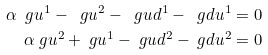<formula> <loc_0><loc_0><loc_500><loc_500>\ \alpha \ g u ^ { 1 } - \ g u ^ { 2 } - \ g u d ^ { 1 } - \ g d u ^ { 1 } & = 0 \\ \alpha \ g u ^ { 2 } + \ g u ^ { 1 } - \ g u d ^ { 2 } - \ g d u ^ { 2 } & = 0</formula> 